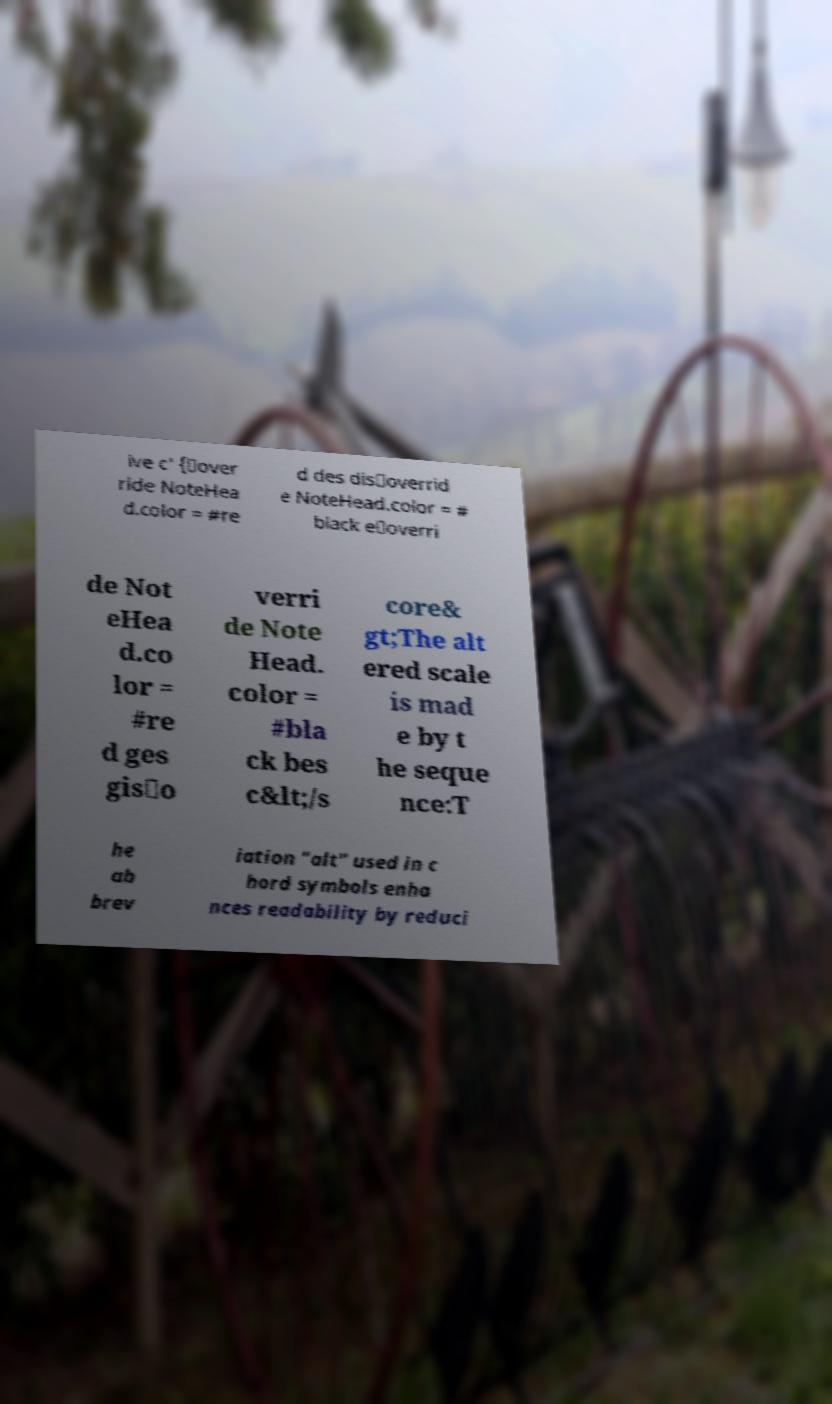Could you extract and type out the text from this image? ive c' {\over ride NoteHea d.color = #re d des dis\overrid e NoteHead.color = # black e\overri de Not eHea d.co lor = #re d ges gis\o verri de Note Head. color = #bla ck bes c&lt;/s core& gt;The alt ered scale is mad e by t he seque nce:T he ab brev iation "alt" used in c hord symbols enha nces readability by reduci 